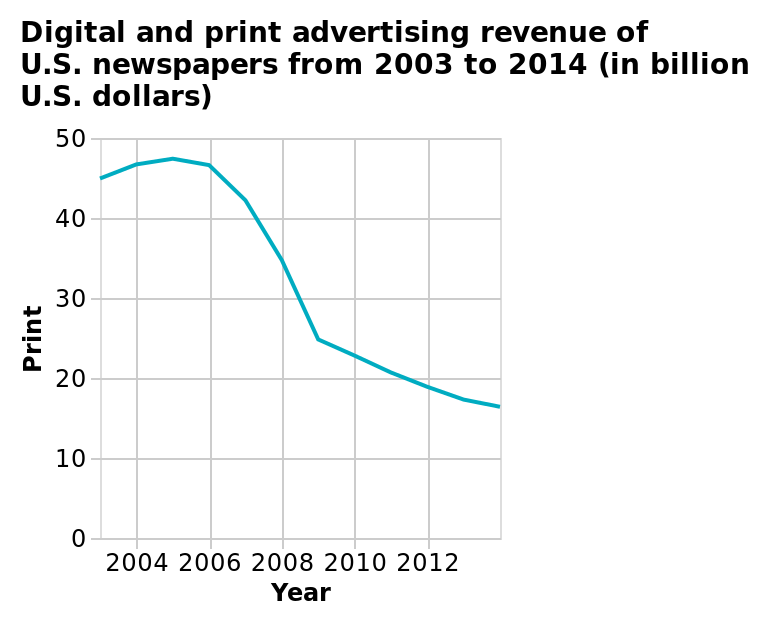<image>
please describe the details of the chart Digital and print advertising revenue of U.S. newspapers from 2003 to 2014 (in billion U.S. dollars) is a line plot. A linear scale with a minimum of 2004 and a maximum of 2012 can be seen on the x-axis, marked Year. There is a linear scale of range 0 to 50 on the y-axis, marked Print. Did the advertising revenue rise or fall from 2005 to 2019?  The advertising revenue fell from 2005 to 2019. 